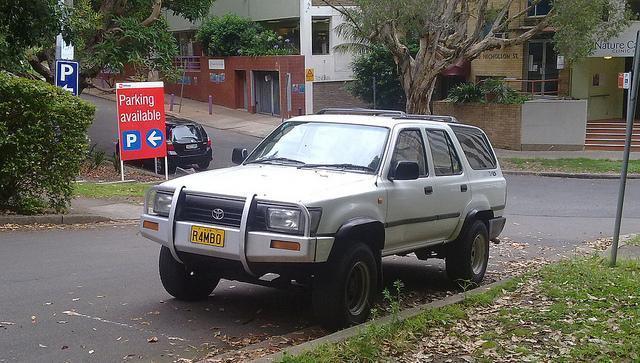How many cars are parked on the street?
Give a very brief answer. 2. How many parking meters are combined?
Give a very brief answer. 0. How many trucks are in the photo?
Give a very brief answer. 1. How many cars are there?
Give a very brief answer. 2. How many of these people are riding skateboards?
Give a very brief answer. 0. 